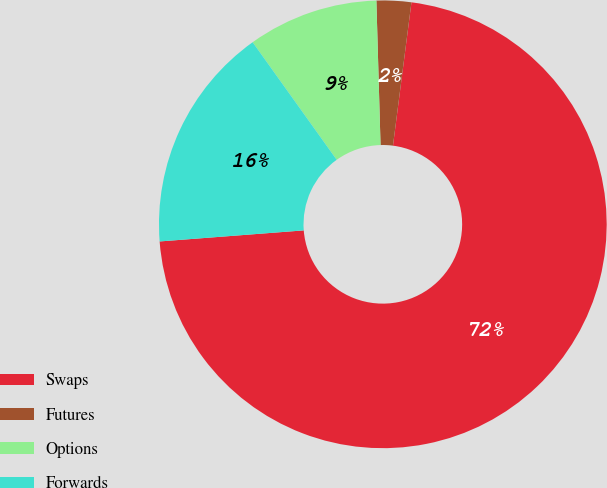<chart> <loc_0><loc_0><loc_500><loc_500><pie_chart><fcel>Swaps<fcel>Futures<fcel>Options<fcel>Forwards<nl><fcel>71.74%<fcel>2.5%<fcel>9.42%<fcel>16.34%<nl></chart> 